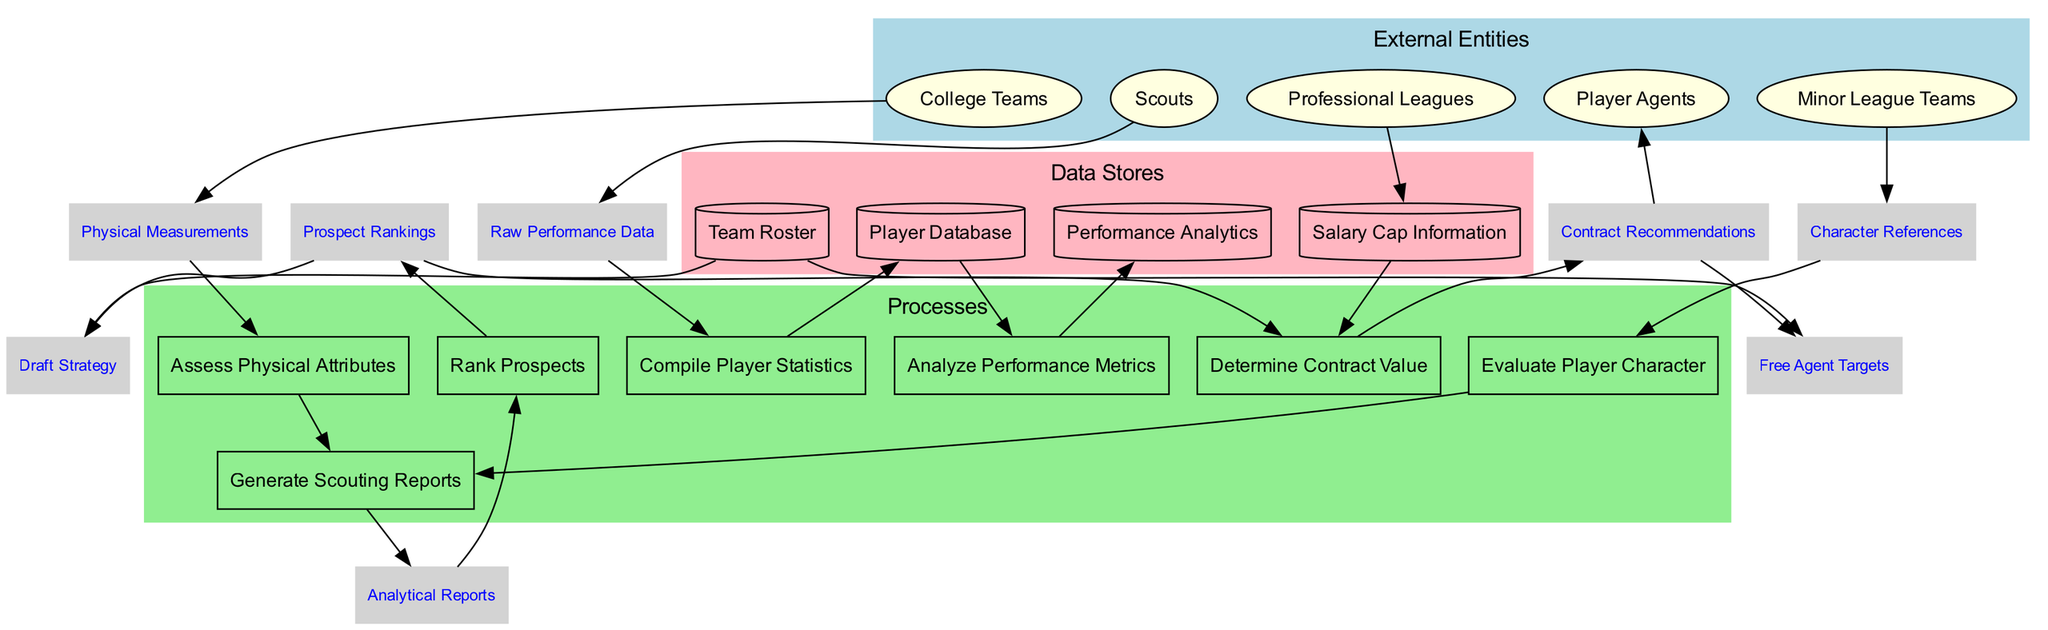What are the external entities in this diagram? The external entities are listed in a specific section of the diagram and include Scouts, College Teams, Minor League Teams, Professional Leagues, and Player Agents.
Answer: Scouts, College Teams, Minor League Teams, Professional Leagues, Player Agents How many processes are represented in the diagram? By counting the processes listed in the respective section of the diagram, we find there are seven processes: Compile Player Statistics, Analyze Performance Metrics, Assess Physical Attributes, Evaluate Player Character, Generate Scouting Reports, Rank Prospects, and Determine Contract Value.
Answer: Seven What data flow connects Scouts to the Compile Player Statistics process? The connection is represented as the Raw Performance Data data flow, which indicates that Scouts provide this raw data to begin the process of compiling player statistics.
Answer: Raw Performance Data Which process generates the Analytical Reports? The process that generates Analytical Reports is Generate Scouting Reports, as shown by the connection in the diagram leading from this process to the Analytical Reports data flow.
Answer: Generate Scouting Reports How does Salary Cap Information impact the Determine Contract Value process? The Salary Cap Information data flow feeds directly into the Determine Contract Value process, indicating that contract valuations take this information into account for free agent signings or drafts.
Answer: Directly What type of data flows into the assess Physical Attributes process? Physical Measurements are depicted as the data flow that enters the Assess Physical Attributes process, indicating the metrics gathered for assessing players' physical traits.
Answer: Physical Measurements How are Contract Recommendations related to Free Agent Targets? The diagram shows that the Contract Recommendations process outputs directly into the Free Agent Targets data flow, indicating that contract decisions made influence potential free agent signings.
Answer: Directly Which process evaluates both player character and physical attributes? The process that evaluates both aspects is Generate Scouting Reports, as it receives data from both Assess Physical Attributes and Evaluate Player Character processes in order to create a holistic scouting report.
Answer: Generate Scouting Reports 